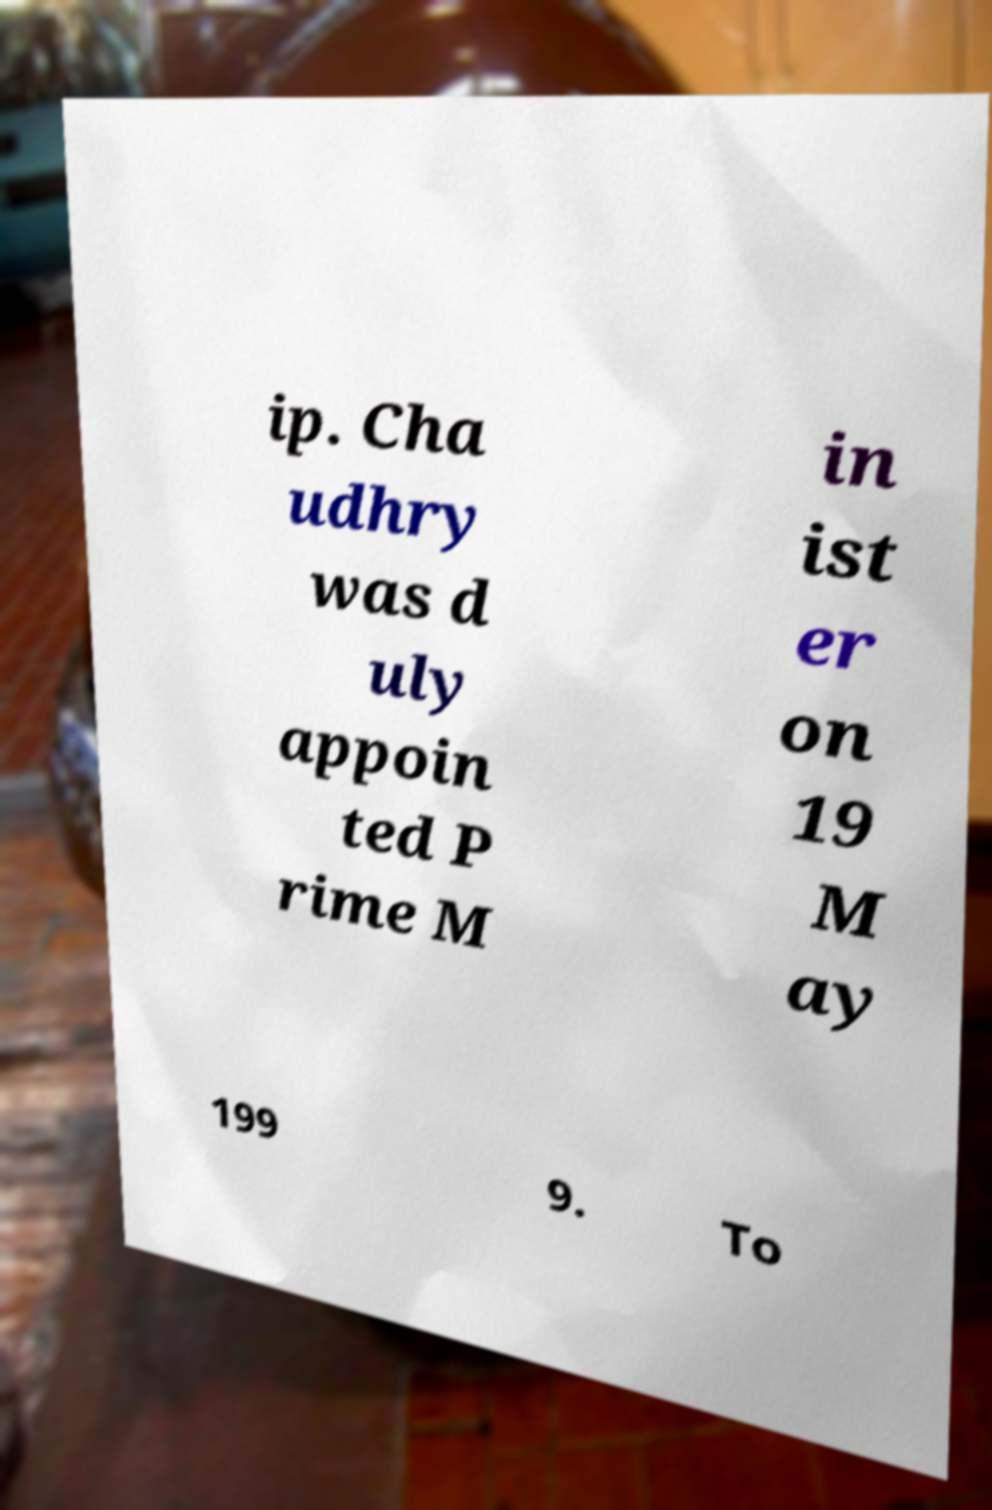Please identify and transcribe the text found in this image. ip. Cha udhry was d uly appoin ted P rime M in ist er on 19 M ay 199 9. To 